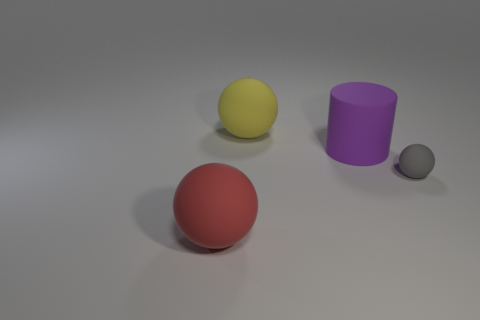Are there any other things that have the same size as the gray rubber thing?
Your answer should be very brief. No. There is a matte sphere that is to the left of the yellow rubber object; is it the same size as the yellow rubber object?
Give a very brief answer. Yes. Are there fewer purple things than big balls?
Provide a short and direct response. Yes. Is there another tiny gray thing made of the same material as the gray thing?
Offer a terse response. No. What is the shape of the large object in front of the gray matte object?
Ensure brevity in your answer.  Sphere. Is the number of red matte spheres that are on the right side of the purple rubber cylinder less than the number of cyan rubber blocks?
Offer a terse response. No. What color is the tiny object that is made of the same material as the purple cylinder?
Provide a succinct answer. Gray. What size is the thing right of the large purple thing?
Give a very brief answer. Small. Is the yellow sphere made of the same material as the small thing?
Offer a terse response. Yes. There is a ball behind the rubber sphere that is on the right side of the large yellow matte thing; are there any small things that are right of it?
Provide a succinct answer. Yes. 